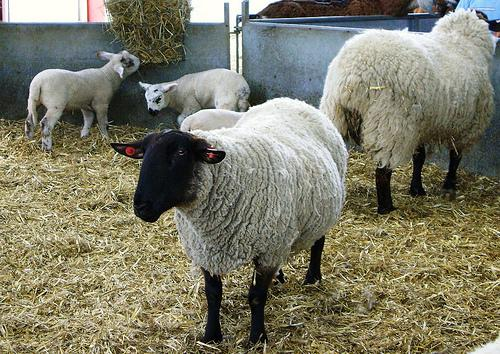Question: what animals are shown?
Choices:
A. Goat.
B. Sheep.
C. Cow.
D. Pig.
Answer with the letter. Answer: B Question: what covers the ground?
Choices:
A. Hay.
B. Dirt.
C. Straw.
D. Mud.
Answer with the letter. Answer: C Question: what color face does the front sheep have?
Choices:
A. Red.
B. White.
C. Black.
D. Blue.
Answer with the letter. Answer: C Question: what color tags are in the sheep's ears?
Choices:
A. White.
B. Red.
C. Blue.
D. Green.
Answer with the letter. Answer: B Question: where are the sheep?
Choices:
A. In a pen.
B. In a barn.
C. In a field.
D. On a farm.
Answer with the letter. Answer: A 